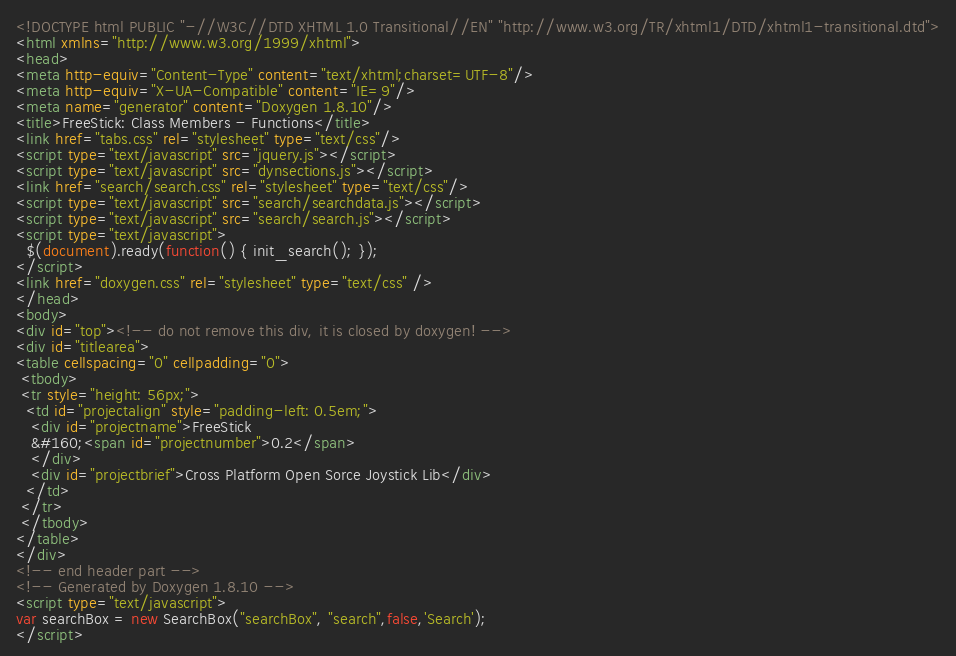Convert code to text. <code><loc_0><loc_0><loc_500><loc_500><_HTML_><!DOCTYPE html PUBLIC "-//W3C//DTD XHTML 1.0 Transitional//EN" "http://www.w3.org/TR/xhtml1/DTD/xhtml1-transitional.dtd">
<html xmlns="http://www.w3.org/1999/xhtml">
<head>
<meta http-equiv="Content-Type" content="text/xhtml;charset=UTF-8"/>
<meta http-equiv="X-UA-Compatible" content="IE=9"/>
<meta name="generator" content="Doxygen 1.8.10"/>
<title>FreeStick: Class Members - Functions</title>
<link href="tabs.css" rel="stylesheet" type="text/css"/>
<script type="text/javascript" src="jquery.js"></script>
<script type="text/javascript" src="dynsections.js"></script>
<link href="search/search.css" rel="stylesheet" type="text/css"/>
<script type="text/javascript" src="search/searchdata.js"></script>
<script type="text/javascript" src="search/search.js"></script>
<script type="text/javascript">
  $(document).ready(function() { init_search(); });
</script>
<link href="doxygen.css" rel="stylesheet" type="text/css" />
</head>
<body>
<div id="top"><!-- do not remove this div, it is closed by doxygen! -->
<div id="titlearea">
<table cellspacing="0" cellpadding="0">
 <tbody>
 <tr style="height: 56px;">
  <td id="projectalign" style="padding-left: 0.5em;">
   <div id="projectname">FreeStick
   &#160;<span id="projectnumber">0.2</span>
   </div>
   <div id="projectbrief">Cross Platform Open Sorce Joystick Lib</div>
  </td>
 </tr>
 </tbody>
</table>
</div>
<!-- end header part -->
<!-- Generated by Doxygen 1.8.10 -->
<script type="text/javascript">
var searchBox = new SearchBox("searchBox", "search",false,'Search');
</script></code> 